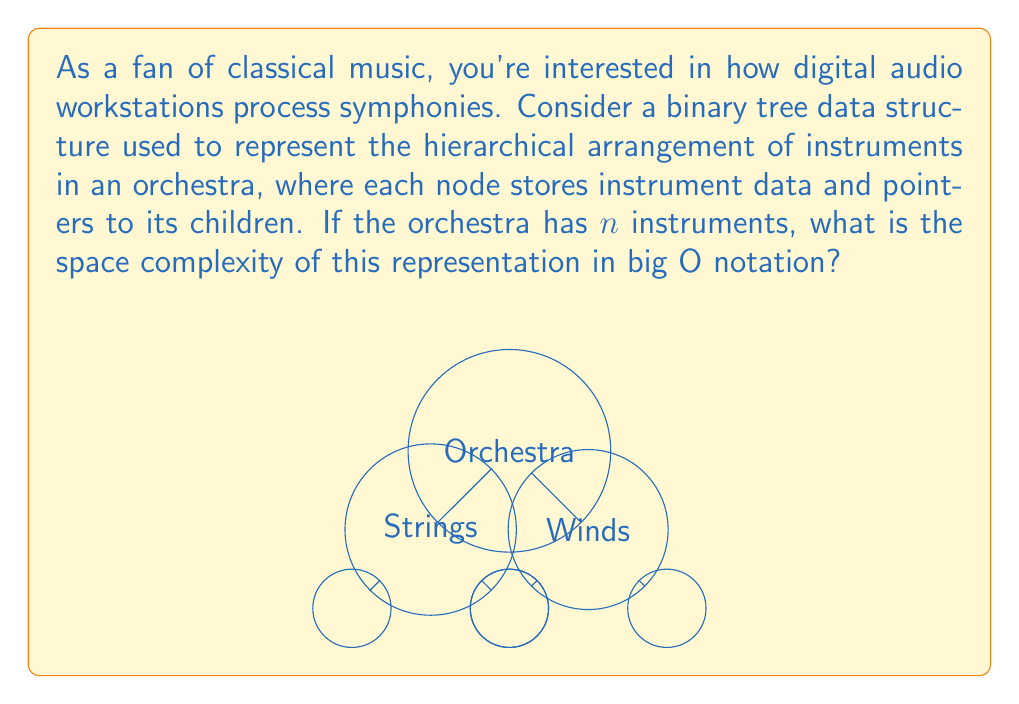Provide a solution to this math problem. Let's approach this step-by-step:

1) In a binary tree, each node typically contains:
   - Data (instrument information)
   - Two pointers (left and right child)

2) For $n$ instruments, we will have $n$ nodes in the tree.

3) Space required for each node:
   - Instrument data: $O(1)$ (assuming fixed-size data for each instrument)
   - Two pointers: $O(1)$ (each pointer is a fixed-size memory address)
   Total per node: $O(1) + O(1) = O(1)$

4) Total space for $n$ nodes:
   $O(1) * n = O(n)$

5) The tree structure itself (pointers) also requires space:
   - In a binary tree, the number of edges (pointers) is always one less than the number of nodes.
   - So, we have $n-1$ edges, each requiring constant space.
   - This also contributes $O(n)$ to the space complexity.

6) Combining the space for nodes and edges:
   $O(n) + O(n) = O(n)$

Therefore, the overall space complexity is $O(n)$, linear in the number of instruments.
Answer: $O(n)$ 